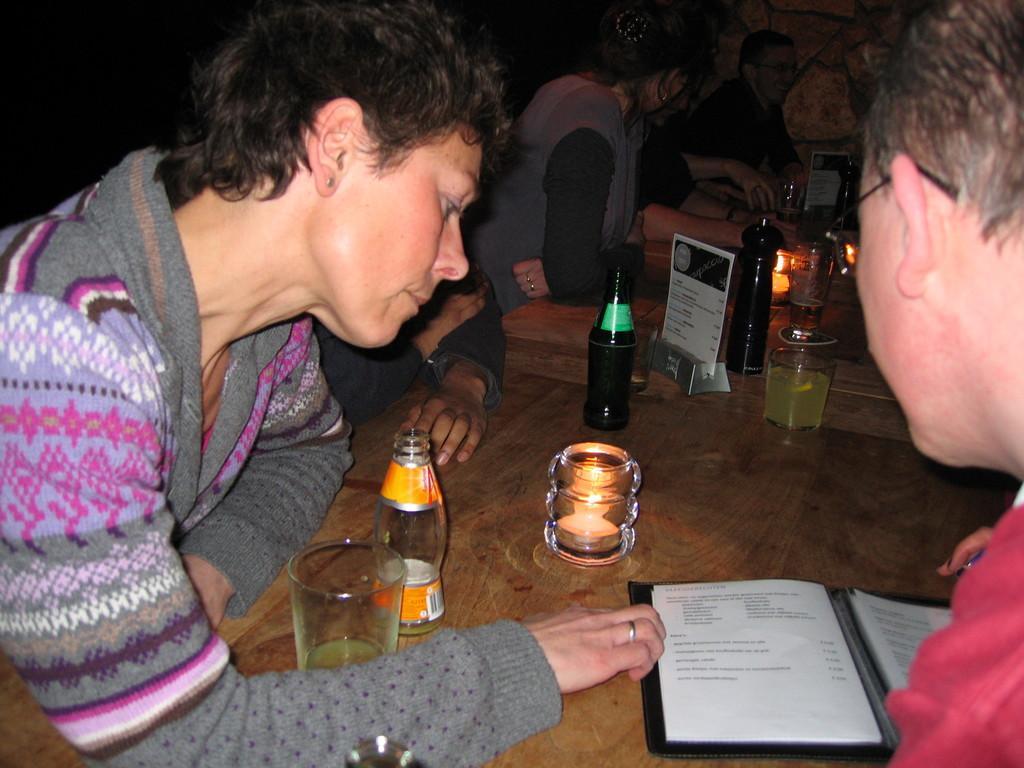How would you summarize this image in a sentence or two? In this image we can see persons sitting around the table. On the table we can see grass, beverage bottle, candle, menu, book and lamp. 